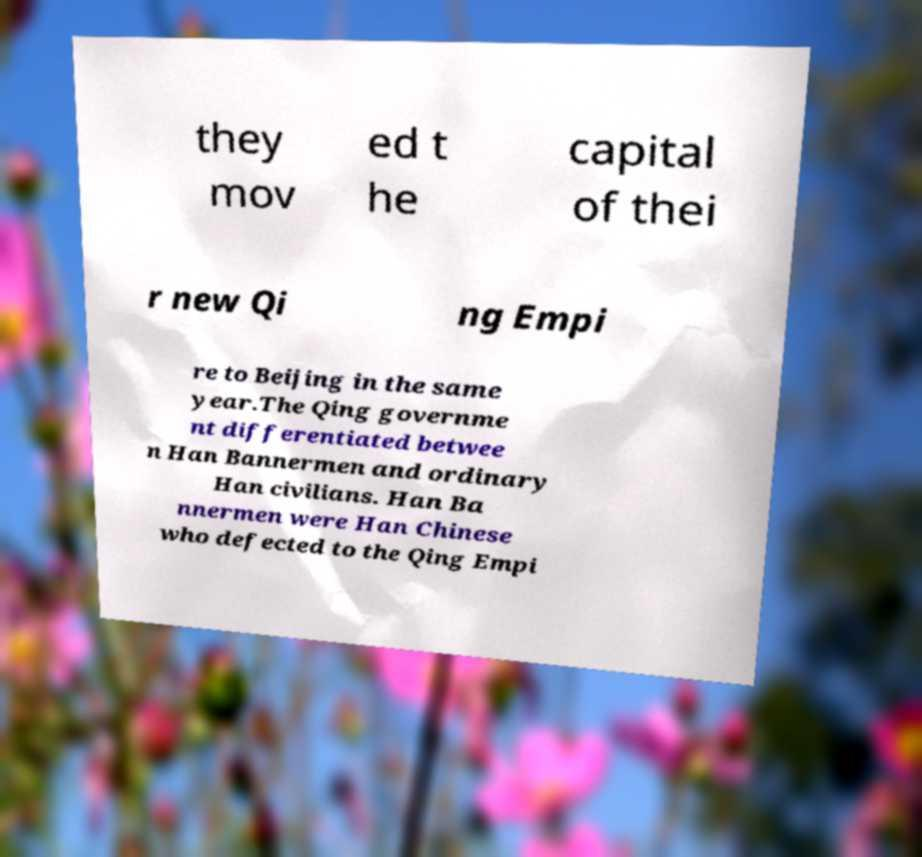Please identify and transcribe the text found in this image. they mov ed t he capital of thei r new Qi ng Empi re to Beijing in the same year.The Qing governme nt differentiated betwee n Han Bannermen and ordinary Han civilians. Han Ba nnermen were Han Chinese who defected to the Qing Empi 